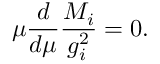<formula> <loc_0><loc_0><loc_500><loc_500>\mu \frac { d } { d \mu } \frac { M _ { i } } { g _ { i } ^ { 2 } } = 0 .</formula> 